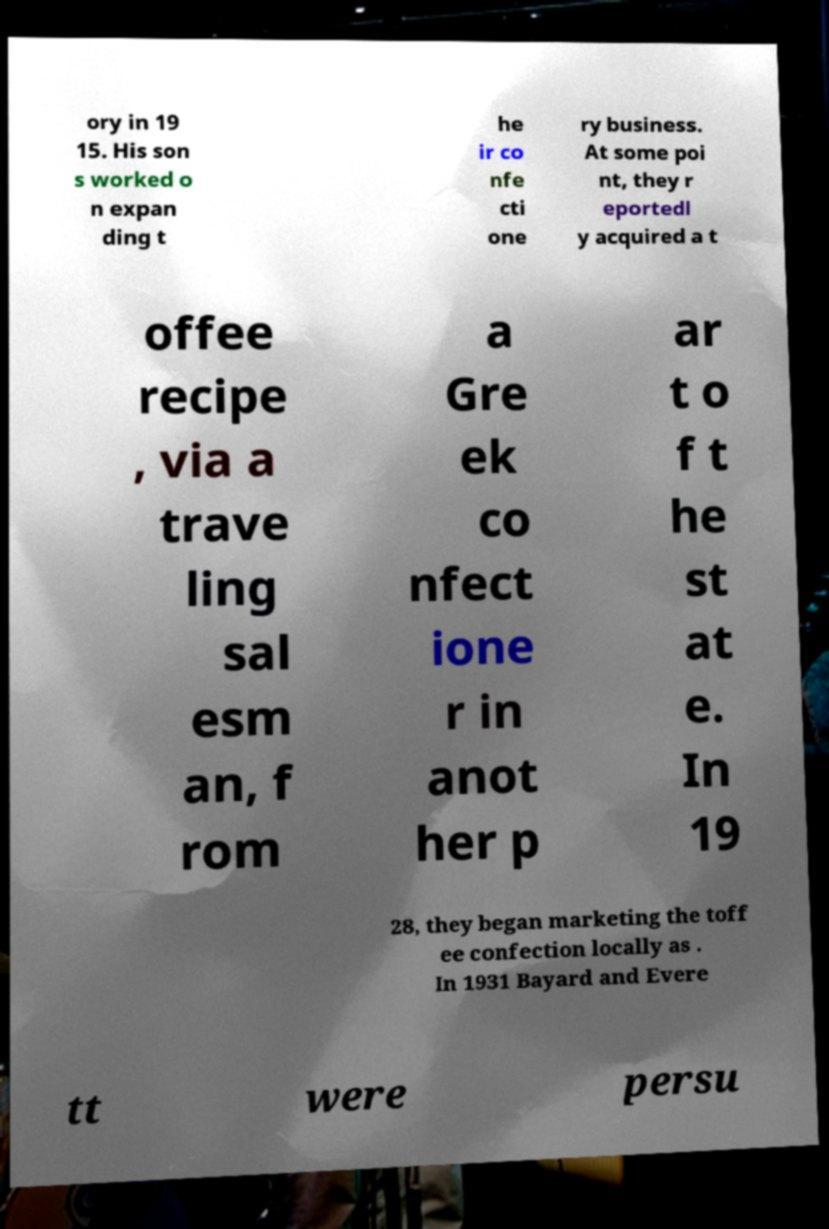Please read and relay the text visible in this image. What does it say? ory in 19 15. His son s worked o n expan ding t he ir co nfe cti one ry business. At some poi nt, they r eportedl y acquired a t offee recipe , via a trave ling sal esm an, f rom a Gre ek co nfect ione r in anot her p ar t o f t he st at e. In 19 28, they began marketing the toff ee confection locally as . In 1931 Bayard and Evere tt were persu 